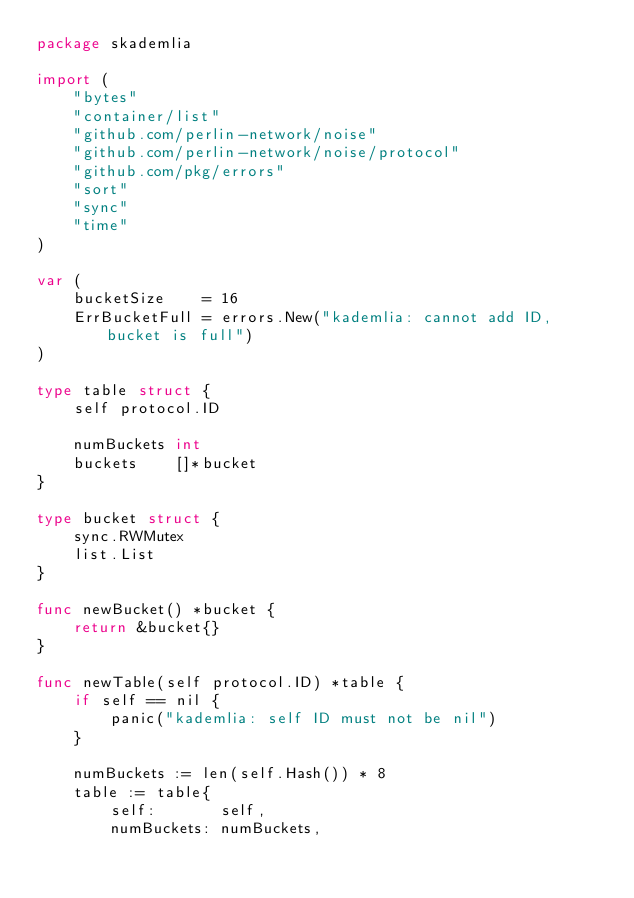Convert code to text. <code><loc_0><loc_0><loc_500><loc_500><_Go_>package skademlia

import (
	"bytes"
	"container/list"
	"github.com/perlin-network/noise"
	"github.com/perlin-network/noise/protocol"
	"github.com/pkg/errors"
	"sort"
	"sync"
	"time"
)

var (
	bucketSize    = 16
	ErrBucketFull = errors.New("kademlia: cannot add ID, bucket is full")
)

type table struct {
	self protocol.ID

	numBuckets int
	buckets    []*bucket
}

type bucket struct {
	sync.RWMutex
	list.List
}

func newBucket() *bucket {
	return &bucket{}
}

func newTable(self protocol.ID) *table {
	if self == nil {
		panic("kademlia: self ID must not be nil")
	}

	numBuckets := len(self.Hash()) * 8
	table := table{
		self:       self,
		numBuckets: numBuckets,</code> 